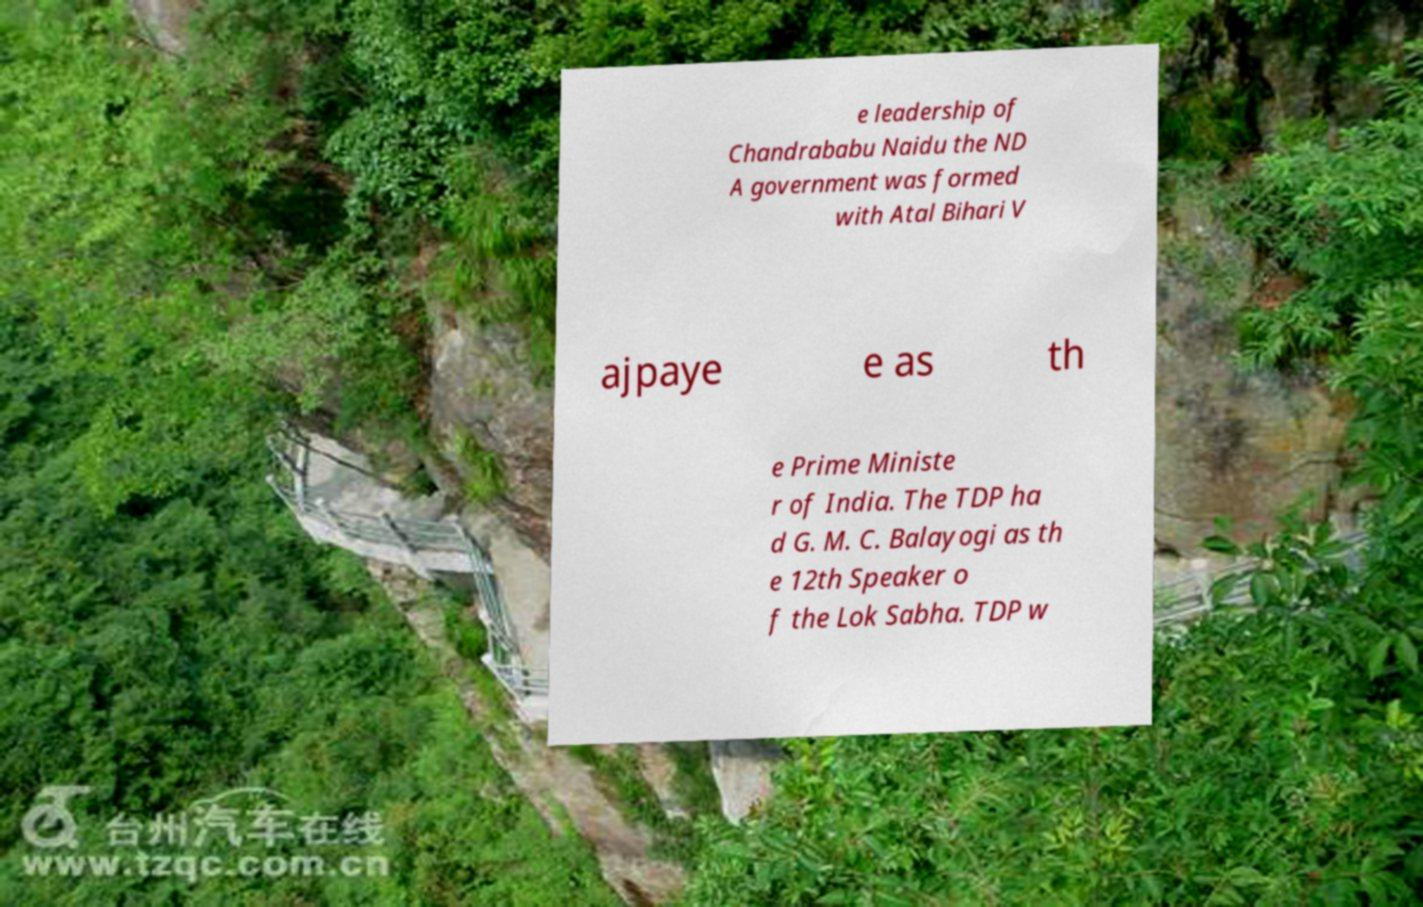For documentation purposes, I need the text within this image transcribed. Could you provide that? e leadership of Chandrababu Naidu the ND A government was formed with Atal Bihari V ajpaye e as th e Prime Ministe r of India. The TDP ha d G. M. C. Balayogi as th e 12th Speaker o f the Lok Sabha. TDP w 